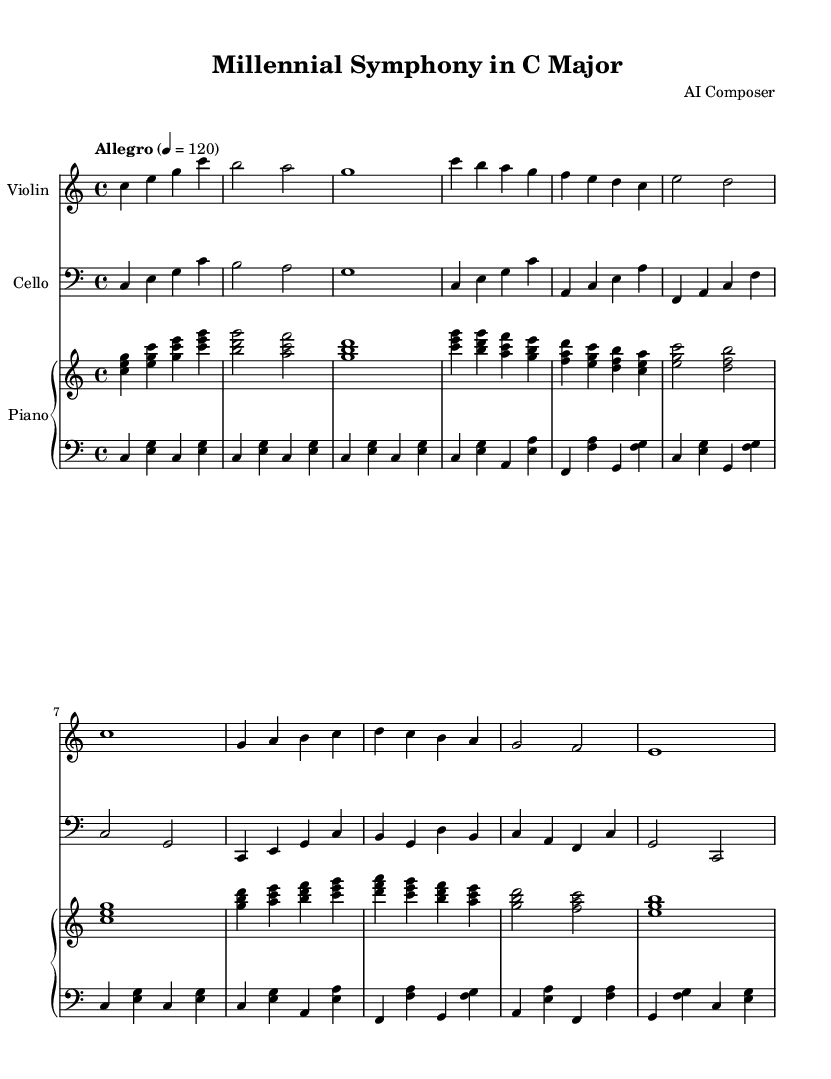What is the key signature of this music? The key signature is indicated at the beginning of the score after the clef. It shows that there are no sharps or flats present, confirming that the piece is in C major.
Answer: C major What is the time signature of this music? The time signature is given at the start of the score. It is displayed as "4/4", which means there are four beats in a measure and a quarter note receives one beat.
Answer: 4/4 What is the tempo marking for this piece? The tempo marking is stated on the score, indicating the speed of the music. It shows "Allegro" with a metronome marking of 120 beats per minute, suggesting a fast and lively pace.
Answer: Allegro, 120 How many themes are presented in this composition? The sheet music shows two distinct themes labeled A and B in the notation, indicating two primary musical ideas that form the structure of the piece.
Answer: Two What instrument plays the highest part in the score? By examining the staves, the instrument with the highest pitch range is the violin. Its part is positioned on the top staff, confirming that it plays the highest notes in this composition.
Answer: Violin Which instrument is featured in the bass clef? The bass clef is clearly indicated at the beginning of one staff and is primarily used for the cello part, which plays lower pitch notes compared to the other instruments.
Answer: Cello What is the form of the composition based on thematic presentation? The music combines motifs in a structured format, alternating between the two themes (A and B) that are used in repetition, suggesting a classical form like Sonata or Theme and Variations.
Answer: Theme and Variations 